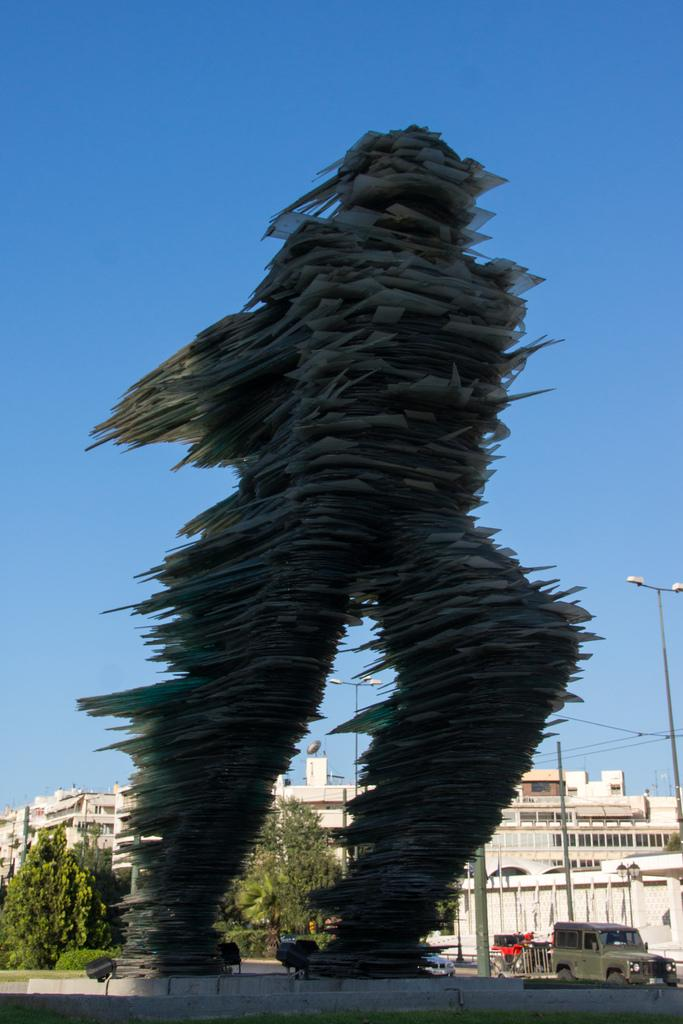What is the main subject in the foreground of the image? There is a paper statue in the foreground of the image. What can be seen in the background of the image? There are buildings, vehicles, trees, poles, and the sky visible in the background of the image. Can you provide any suggestions on how to help the paper statue look more realistic in the image? The image does not require any suggestions or help, as it is a static representation of a paper statue. The focus should be on accurately describing the elements present in the image. 